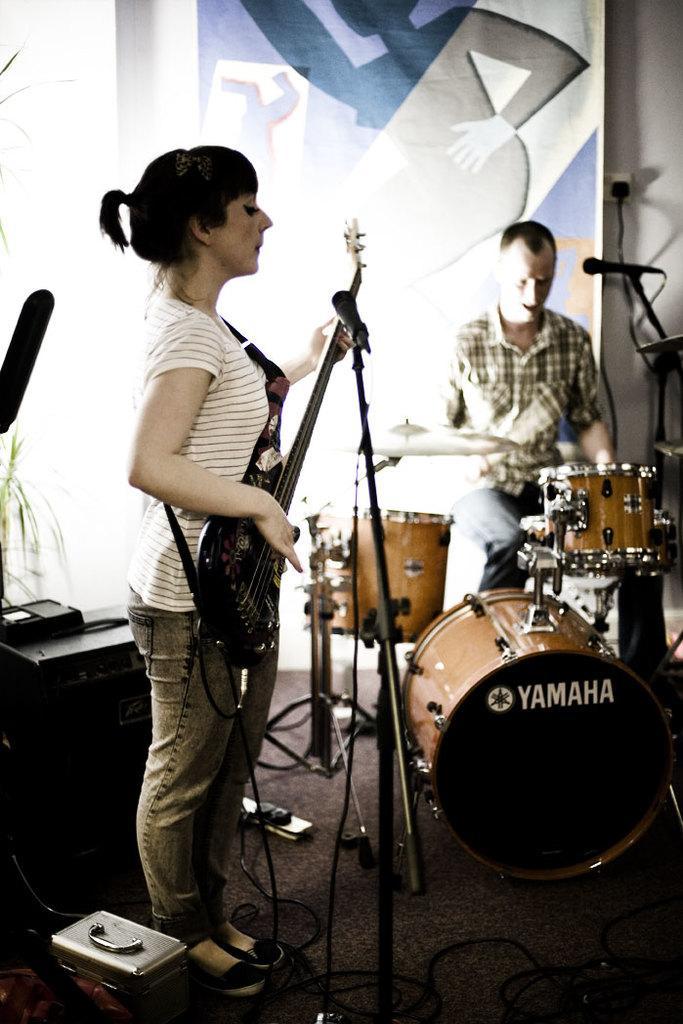How would you summarize this image in a sentence or two? In this image In the middle there is a woman she wears t shirt and trouser she is playing guitar, In front of her there is a mic. On the right there is a man he is playing drums. In the background there is a poster and wall. 